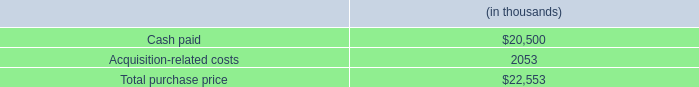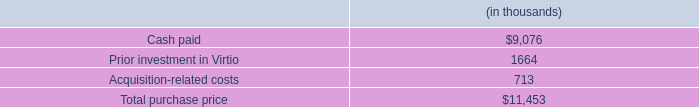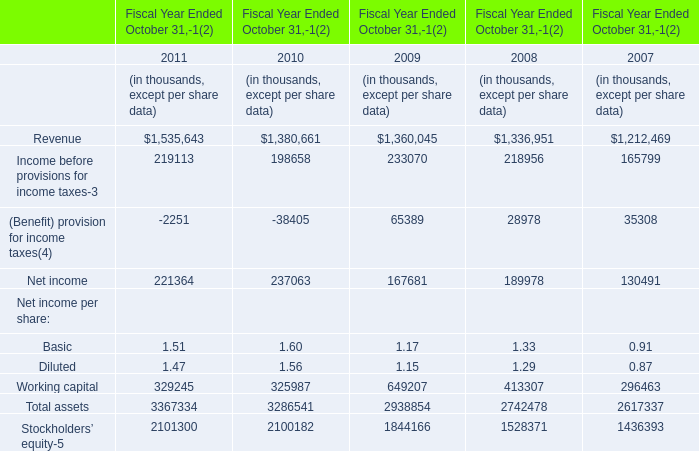What is the growing rate of working capital in the year with the most net income? 
Computations: ((325987 - 649207) / 649207)
Answer: -0.49787. 